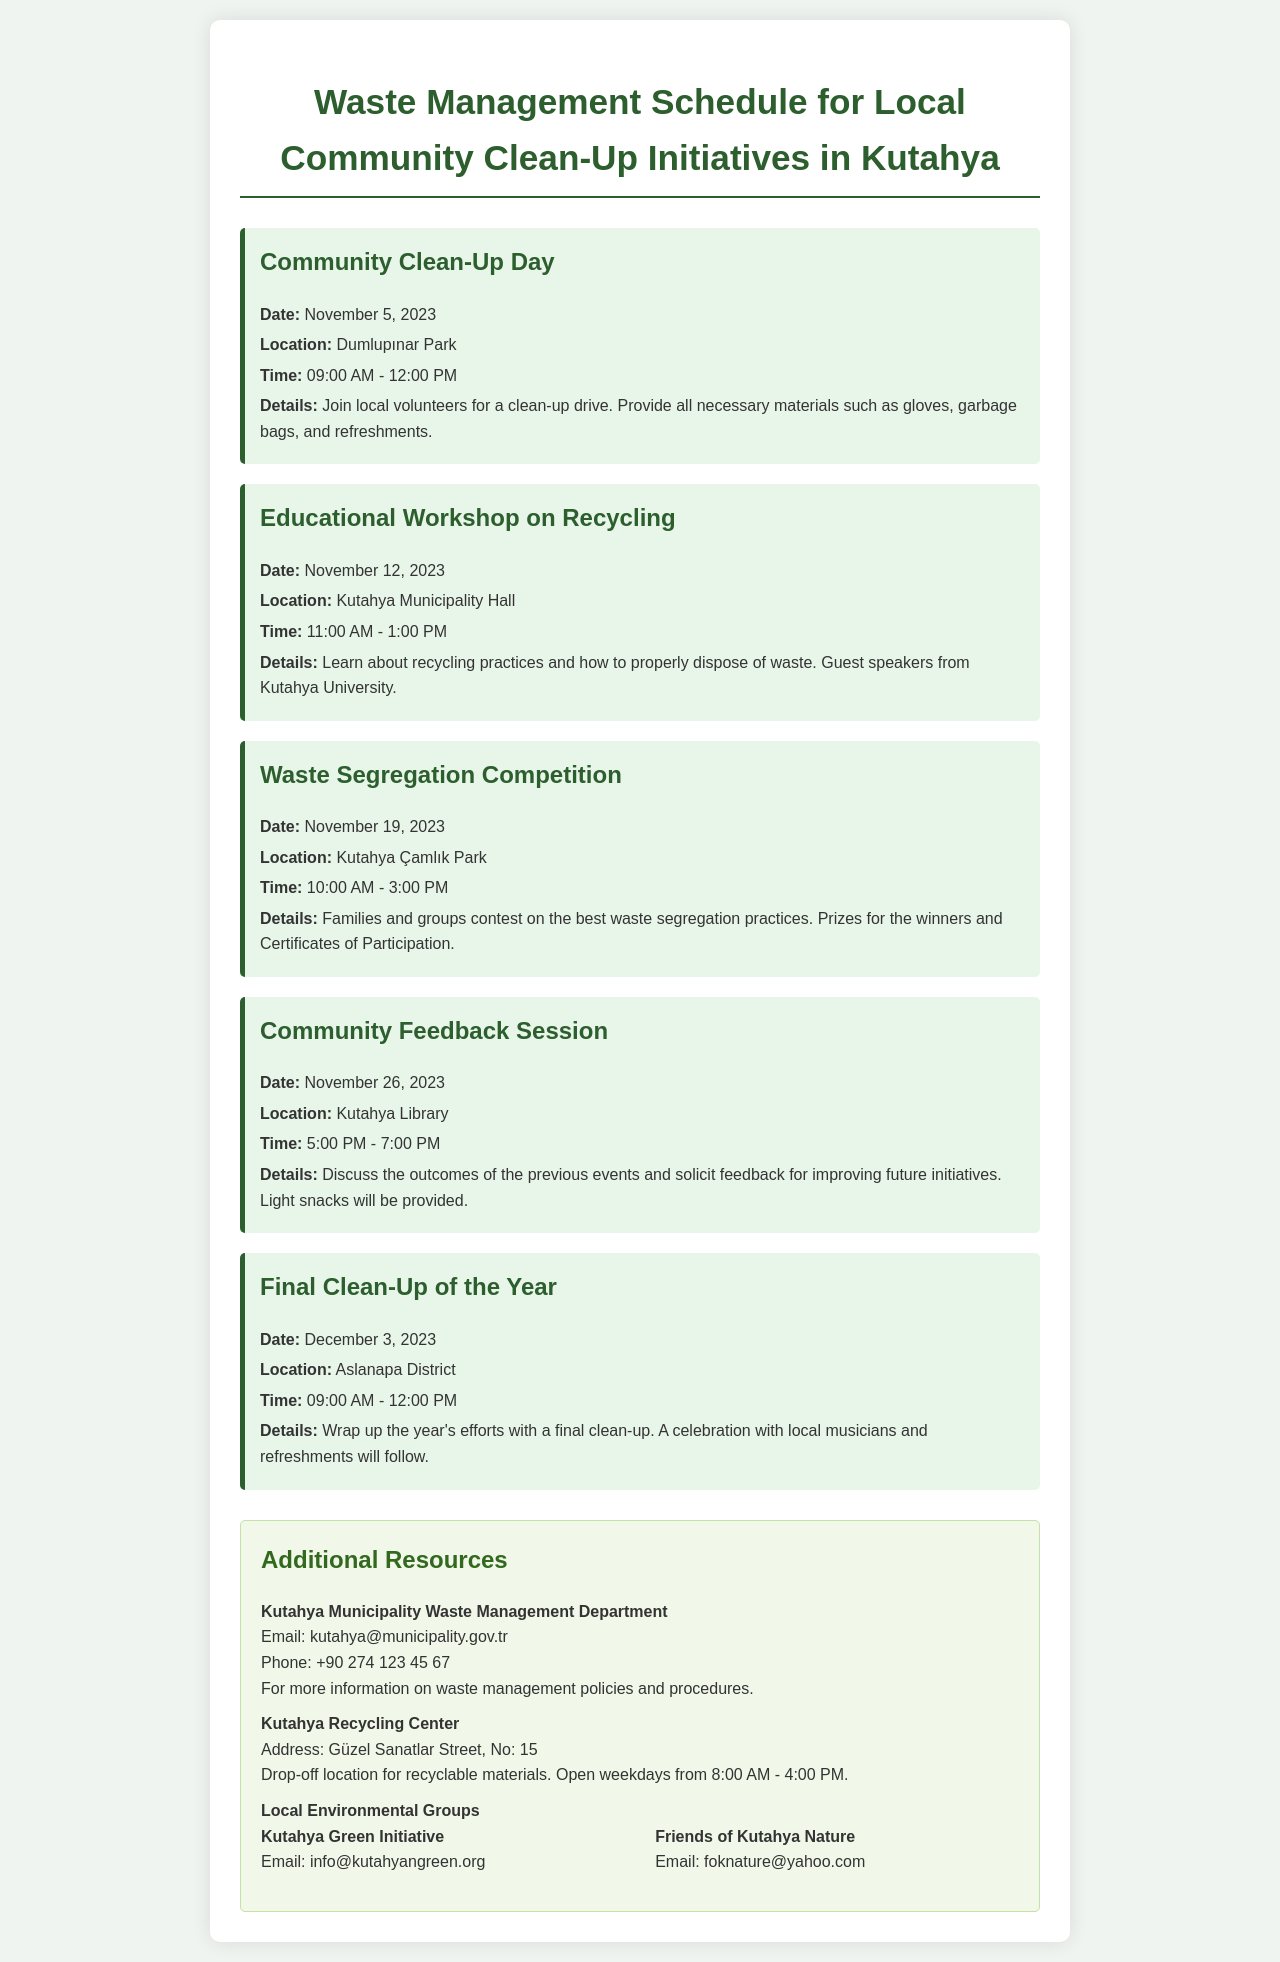What is the date of the Community Clean-Up Day? The date of the Community Clean-Up Day is mentioned in the schedule as November 5, 2023.
Answer: November 5, 2023 Where is the Educational Workshop on Recycling held? The location of the Educational Workshop on Recycling is specified as Kutahya Municipality Hall.
Answer: Kutahya Municipality Hall What time does the Waste Segregation Competition start? The starting time for the Waste Segregation Competition is highlighted as 10:00 AM.
Answer: 10:00 AM What event occurs on November 26, 2023? The event scheduled for November 26, 2023, is the Community Feedback Session.
Answer: Community Feedback Session Which location is associated with the Final Clean-Up of the Year? The Final Clean-Up of the Year takes place in Aslanapa District, as stated in the document.
Answer: Aslanapa District How long will the Community Clean-Up Day last? The duration of the Community Clean-Up Day is from 09:00 AM to 12:00 PM, which is 3 hours.
Answer: 3 hours What activity is associated with the Waste Segregation Competition? The document states that families and groups will contest on the best waste segregation practices.
Answer: Best waste segregation practices What is provided at the Community Feedback Session? Light snacks are mentioned as being provided during the Community Feedback Session.
Answer: Light snacks What is the email of the Kutahya Green Initiative? The document lists the email for Kutahya Green Initiative as info@kutahyangreen.org.
Answer: info@kutahyangreen.org 